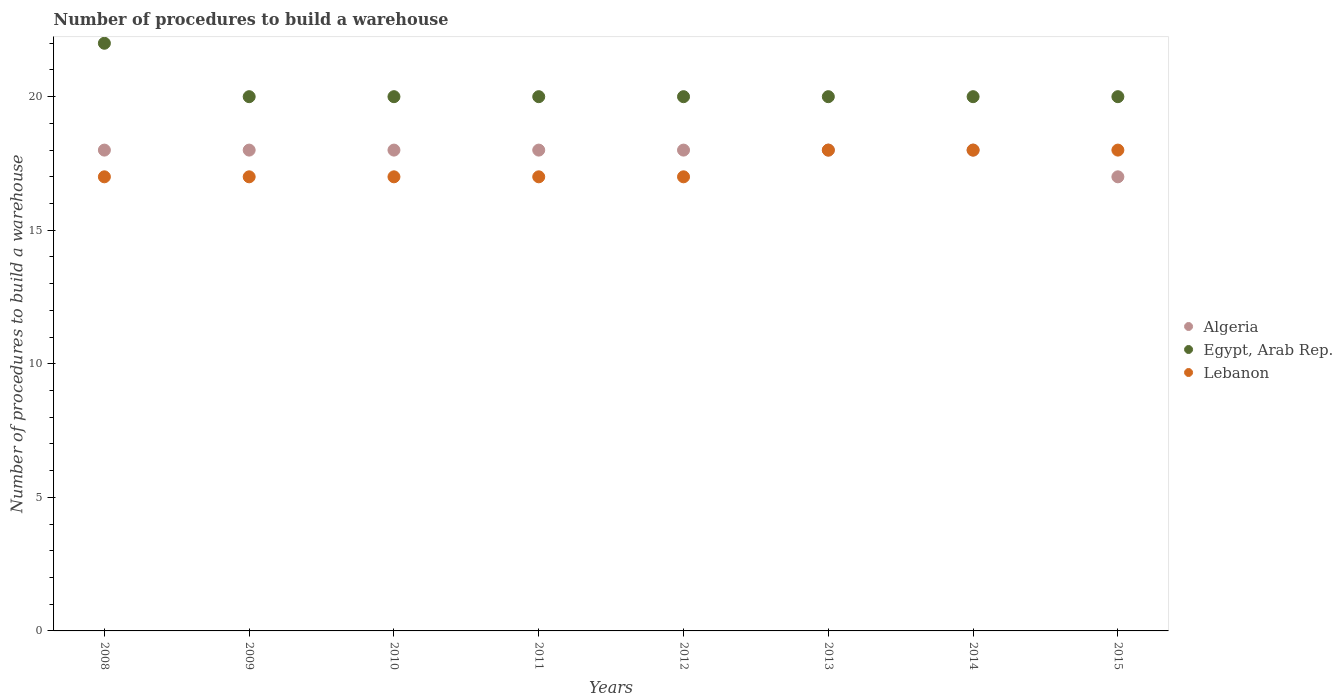What is the number of procedures to build a warehouse in in Lebanon in 2009?
Make the answer very short. 17. Across all years, what is the maximum number of procedures to build a warehouse in in Egypt, Arab Rep.?
Your response must be concise. 22. Across all years, what is the minimum number of procedures to build a warehouse in in Lebanon?
Make the answer very short. 17. In which year was the number of procedures to build a warehouse in in Egypt, Arab Rep. maximum?
Keep it short and to the point. 2008. In which year was the number of procedures to build a warehouse in in Egypt, Arab Rep. minimum?
Give a very brief answer. 2009. What is the total number of procedures to build a warehouse in in Lebanon in the graph?
Give a very brief answer. 139. What is the difference between the number of procedures to build a warehouse in in Algeria in 2008 and that in 2014?
Offer a terse response. 0. What is the difference between the number of procedures to build a warehouse in in Algeria in 2008 and the number of procedures to build a warehouse in in Egypt, Arab Rep. in 2010?
Your answer should be compact. -2. What is the average number of procedures to build a warehouse in in Algeria per year?
Provide a short and direct response. 17.88. In the year 2010, what is the difference between the number of procedures to build a warehouse in in Lebanon and number of procedures to build a warehouse in in Algeria?
Provide a short and direct response. -1. What is the ratio of the number of procedures to build a warehouse in in Algeria in 2008 to that in 2015?
Provide a short and direct response. 1.06. Is the number of procedures to build a warehouse in in Algeria in 2011 less than that in 2012?
Your answer should be compact. No. What is the difference between the highest and the lowest number of procedures to build a warehouse in in Egypt, Arab Rep.?
Provide a short and direct response. 2. Is the sum of the number of procedures to build a warehouse in in Algeria in 2008 and 2011 greater than the maximum number of procedures to build a warehouse in in Lebanon across all years?
Make the answer very short. Yes. Is the number of procedures to build a warehouse in in Egypt, Arab Rep. strictly less than the number of procedures to build a warehouse in in Lebanon over the years?
Offer a very short reply. No. Does the graph contain grids?
Your answer should be very brief. No. Where does the legend appear in the graph?
Offer a very short reply. Center right. How are the legend labels stacked?
Provide a short and direct response. Vertical. What is the title of the graph?
Your response must be concise. Number of procedures to build a warehouse. What is the label or title of the Y-axis?
Keep it short and to the point. Number of procedures to build a warehouse. What is the Number of procedures to build a warehouse of Egypt, Arab Rep. in 2008?
Your answer should be very brief. 22. What is the Number of procedures to build a warehouse in Lebanon in 2008?
Keep it short and to the point. 17. What is the Number of procedures to build a warehouse of Algeria in 2010?
Your answer should be very brief. 18. What is the Number of procedures to build a warehouse of Egypt, Arab Rep. in 2010?
Ensure brevity in your answer.  20. What is the Number of procedures to build a warehouse in Lebanon in 2010?
Provide a succinct answer. 17. What is the Number of procedures to build a warehouse in Algeria in 2012?
Ensure brevity in your answer.  18. What is the Number of procedures to build a warehouse of Egypt, Arab Rep. in 2012?
Your response must be concise. 20. What is the Number of procedures to build a warehouse of Lebanon in 2013?
Make the answer very short. 18. What is the Number of procedures to build a warehouse in Algeria in 2014?
Your response must be concise. 18. What is the Number of procedures to build a warehouse of Lebanon in 2014?
Offer a terse response. 18. What is the Number of procedures to build a warehouse of Lebanon in 2015?
Make the answer very short. 18. Across all years, what is the maximum Number of procedures to build a warehouse of Egypt, Arab Rep.?
Provide a succinct answer. 22. Across all years, what is the minimum Number of procedures to build a warehouse of Algeria?
Offer a terse response. 17. What is the total Number of procedures to build a warehouse of Algeria in the graph?
Your answer should be very brief. 143. What is the total Number of procedures to build a warehouse of Egypt, Arab Rep. in the graph?
Offer a terse response. 162. What is the total Number of procedures to build a warehouse of Lebanon in the graph?
Offer a terse response. 139. What is the difference between the Number of procedures to build a warehouse of Egypt, Arab Rep. in 2008 and that in 2009?
Your response must be concise. 2. What is the difference between the Number of procedures to build a warehouse in Egypt, Arab Rep. in 2008 and that in 2010?
Provide a succinct answer. 2. What is the difference between the Number of procedures to build a warehouse of Algeria in 2008 and that in 2012?
Your answer should be compact. 0. What is the difference between the Number of procedures to build a warehouse in Egypt, Arab Rep. in 2008 and that in 2012?
Give a very brief answer. 2. What is the difference between the Number of procedures to build a warehouse in Lebanon in 2008 and that in 2012?
Offer a very short reply. 0. What is the difference between the Number of procedures to build a warehouse in Egypt, Arab Rep. in 2008 and that in 2013?
Offer a very short reply. 2. What is the difference between the Number of procedures to build a warehouse in Egypt, Arab Rep. in 2008 and that in 2014?
Give a very brief answer. 2. What is the difference between the Number of procedures to build a warehouse in Lebanon in 2008 and that in 2014?
Your answer should be compact. -1. What is the difference between the Number of procedures to build a warehouse of Lebanon in 2008 and that in 2015?
Offer a terse response. -1. What is the difference between the Number of procedures to build a warehouse of Algeria in 2009 and that in 2010?
Provide a succinct answer. 0. What is the difference between the Number of procedures to build a warehouse of Egypt, Arab Rep. in 2009 and that in 2010?
Make the answer very short. 0. What is the difference between the Number of procedures to build a warehouse in Lebanon in 2009 and that in 2010?
Your answer should be very brief. 0. What is the difference between the Number of procedures to build a warehouse in Algeria in 2009 and that in 2011?
Your response must be concise. 0. What is the difference between the Number of procedures to build a warehouse in Egypt, Arab Rep. in 2009 and that in 2011?
Offer a very short reply. 0. What is the difference between the Number of procedures to build a warehouse in Egypt, Arab Rep. in 2009 and that in 2012?
Keep it short and to the point. 0. What is the difference between the Number of procedures to build a warehouse in Lebanon in 2009 and that in 2012?
Give a very brief answer. 0. What is the difference between the Number of procedures to build a warehouse of Egypt, Arab Rep. in 2009 and that in 2013?
Your response must be concise. 0. What is the difference between the Number of procedures to build a warehouse in Lebanon in 2009 and that in 2013?
Ensure brevity in your answer.  -1. What is the difference between the Number of procedures to build a warehouse of Algeria in 2009 and that in 2014?
Provide a succinct answer. 0. What is the difference between the Number of procedures to build a warehouse of Algeria in 2009 and that in 2015?
Your response must be concise. 1. What is the difference between the Number of procedures to build a warehouse in Lebanon in 2009 and that in 2015?
Provide a succinct answer. -1. What is the difference between the Number of procedures to build a warehouse in Egypt, Arab Rep. in 2010 and that in 2012?
Ensure brevity in your answer.  0. What is the difference between the Number of procedures to build a warehouse of Lebanon in 2010 and that in 2012?
Make the answer very short. 0. What is the difference between the Number of procedures to build a warehouse of Algeria in 2010 and that in 2013?
Ensure brevity in your answer.  0. What is the difference between the Number of procedures to build a warehouse of Egypt, Arab Rep. in 2010 and that in 2013?
Provide a succinct answer. 0. What is the difference between the Number of procedures to build a warehouse of Egypt, Arab Rep. in 2010 and that in 2014?
Provide a succinct answer. 0. What is the difference between the Number of procedures to build a warehouse in Algeria in 2011 and that in 2012?
Provide a short and direct response. 0. What is the difference between the Number of procedures to build a warehouse in Egypt, Arab Rep. in 2011 and that in 2012?
Provide a succinct answer. 0. What is the difference between the Number of procedures to build a warehouse in Egypt, Arab Rep. in 2011 and that in 2013?
Offer a terse response. 0. What is the difference between the Number of procedures to build a warehouse in Lebanon in 2011 and that in 2013?
Provide a succinct answer. -1. What is the difference between the Number of procedures to build a warehouse of Algeria in 2011 and that in 2014?
Your response must be concise. 0. What is the difference between the Number of procedures to build a warehouse in Egypt, Arab Rep. in 2011 and that in 2014?
Provide a short and direct response. 0. What is the difference between the Number of procedures to build a warehouse of Lebanon in 2012 and that in 2013?
Your response must be concise. -1. What is the difference between the Number of procedures to build a warehouse of Algeria in 2012 and that in 2014?
Keep it short and to the point. 0. What is the difference between the Number of procedures to build a warehouse in Egypt, Arab Rep. in 2012 and that in 2014?
Provide a short and direct response. 0. What is the difference between the Number of procedures to build a warehouse in Lebanon in 2012 and that in 2014?
Your response must be concise. -1. What is the difference between the Number of procedures to build a warehouse in Algeria in 2012 and that in 2015?
Make the answer very short. 1. What is the difference between the Number of procedures to build a warehouse of Egypt, Arab Rep. in 2012 and that in 2015?
Make the answer very short. 0. What is the difference between the Number of procedures to build a warehouse in Lebanon in 2012 and that in 2015?
Offer a very short reply. -1. What is the difference between the Number of procedures to build a warehouse of Egypt, Arab Rep. in 2013 and that in 2014?
Provide a succinct answer. 0. What is the difference between the Number of procedures to build a warehouse of Lebanon in 2013 and that in 2015?
Provide a succinct answer. 0. What is the difference between the Number of procedures to build a warehouse in Algeria in 2008 and the Number of procedures to build a warehouse in Egypt, Arab Rep. in 2009?
Give a very brief answer. -2. What is the difference between the Number of procedures to build a warehouse in Egypt, Arab Rep. in 2008 and the Number of procedures to build a warehouse in Lebanon in 2010?
Ensure brevity in your answer.  5. What is the difference between the Number of procedures to build a warehouse in Algeria in 2008 and the Number of procedures to build a warehouse in Lebanon in 2011?
Offer a terse response. 1. What is the difference between the Number of procedures to build a warehouse of Egypt, Arab Rep. in 2008 and the Number of procedures to build a warehouse of Lebanon in 2011?
Make the answer very short. 5. What is the difference between the Number of procedures to build a warehouse of Algeria in 2008 and the Number of procedures to build a warehouse of Egypt, Arab Rep. in 2012?
Your answer should be very brief. -2. What is the difference between the Number of procedures to build a warehouse in Algeria in 2008 and the Number of procedures to build a warehouse in Lebanon in 2012?
Provide a succinct answer. 1. What is the difference between the Number of procedures to build a warehouse in Egypt, Arab Rep. in 2008 and the Number of procedures to build a warehouse in Lebanon in 2014?
Keep it short and to the point. 4. What is the difference between the Number of procedures to build a warehouse in Algeria in 2008 and the Number of procedures to build a warehouse in Egypt, Arab Rep. in 2015?
Your answer should be compact. -2. What is the difference between the Number of procedures to build a warehouse of Algeria in 2009 and the Number of procedures to build a warehouse of Egypt, Arab Rep. in 2010?
Offer a terse response. -2. What is the difference between the Number of procedures to build a warehouse in Algeria in 2009 and the Number of procedures to build a warehouse in Lebanon in 2010?
Ensure brevity in your answer.  1. What is the difference between the Number of procedures to build a warehouse of Algeria in 2009 and the Number of procedures to build a warehouse of Egypt, Arab Rep. in 2011?
Give a very brief answer. -2. What is the difference between the Number of procedures to build a warehouse of Algeria in 2009 and the Number of procedures to build a warehouse of Egypt, Arab Rep. in 2012?
Ensure brevity in your answer.  -2. What is the difference between the Number of procedures to build a warehouse in Egypt, Arab Rep. in 2009 and the Number of procedures to build a warehouse in Lebanon in 2012?
Give a very brief answer. 3. What is the difference between the Number of procedures to build a warehouse in Algeria in 2009 and the Number of procedures to build a warehouse in Egypt, Arab Rep. in 2013?
Make the answer very short. -2. What is the difference between the Number of procedures to build a warehouse in Egypt, Arab Rep. in 2009 and the Number of procedures to build a warehouse in Lebanon in 2013?
Your answer should be compact. 2. What is the difference between the Number of procedures to build a warehouse of Algeria in 2009 and the Number of procedures to build a warehouse of Lebanon in 2014?
Keep it short and to the point. 0. What is the difference between the Number of procedures to build a warehouse in Egypt, Arab Rep. in 2009 and the Number of procedures to build a warehouse in Lebanon in 2014?
Give a very brief answer. 2. What is the difference between the Number of procedures to build a warehouse of Egypt, Arab Rep. in 2009 and the Number of procedures to build a warehouse of Lebanon in 2015?
Your answer should be compact. 2. What is the difference between the Number of procedures to build a warehouse of Algeria in 2010 and the Number of procedures to build a warehouse of Lebanon in 2012?
Your response must be concise. 1. What is the difference between the Number of procedures to build a warehouse in Egypt, Arab Rep. in 2010 and the Number of procedures to build a warehouse in Lebanon in 2012?
Keep it short and to the point. 3. What is the difference between the Number of procedures to build a warehouse in Algeria in 2010 and the Number of procedures to build a warehouse in Lebanon in 2014?
Your response must be concise. 0. What is the difference between the Number of procedures to build a warehouse in Algeria in 2010 and the Number of procedures to build a warehouse in Lebanon in 2015?
Give a very brief answer. 0. What is the difference between the Number of procedures to build a warehouse of Egypt, Arab Rep. in 2010 and the Number of procedures to build a warehouse of Lebanon in 2015?
Give a very brief answer. 2. What is the difference between the Number of procedures to build a warehouse of Egypt, Arab Rep. in 2011 and the Number of procedures to build a warehouse of Lebanon in 2012?
Make the answer very short. 3. What is the difference between the Number of procedures to build a warehouse of Algeria in 2011 and the Number of procedures to build a warehouse of Egypt, Arab Rep. in 2014?
Give a very brief answer. -2. What is the difference between the Number of procedures to build a warehouse of Egypt, Arab Rep. in 2011 and the Number of procedures to build a warehouse of Lebanon in 2014?
Ensure brevity in your answer.  2. What is the difference between the Number of procedures to build a warehouse of Algeria in 2011 and the Number of procedures to build a warehouse of Egypt, Arab Rep. in 2015?
Ensure brevity in your answer.  -2. What is the difference between the Number of procedures to build a warehouse of Algeria in 2012 and the Number of procedures to build a warehouse of Egypt, Arab Rep. in 2013?
Ensure brevity in your answer.  -2. What is the difference between the Number of procedures to build a warehouse in Algeria in 2012 and the Number of procedures to build a warehouse in Lebanon in 2013?
Offer a very short reply. 0. What is the difference between the Number of procedures to build a warehouse in Egypt, Arab Rep. in 2012 and the Number of procedures to build a warehouse in Lebanon in 2013?
Your answer should be very brief. 2. What is the difference between the Number of procedures to build a warehouse in Algeria in 2012 and the Number of procedures to build a warehouse in Lebanon in 2014?
Give a very brief answer. 0. What is the difference between the Number of procedures to build a warehouse of Algeria in 2012 and the Number of procedures to build a warehouse of Egypt, Arab Rep. in 2015?
Your answer should be compact. -2. What is the difference between the Number of procedures to build a warehouse of Algeria in 2012 and the Number of procedures to build a warehouse of Lebanon in 2015?
Make the answer very short. 0. What is the difference between the Number of procedures to build a warehouse in Egypt, Arab Rep. in 2012 and the Number of procedures to build a warehouse in Lebanon in 2015?
Offer a very short reply. 2. What is the difference between the Number of procedures to build a warehouse of Algeria in 2013 and the Number of procedures to build a warehouse of Egypt, Arab Rep. in 2014?
Your answer should be very brief. -2. What is the difference between the Number of procedures to build a warehouse in Algeria in 2013 and the Number of procedures to build a warehouse in Lebanon in 2015?
Keep it short and to the point. 0. What is the difference between the Number of procedures to build a warehouse of Egypt, Arab Rep. in 2014 and the Number of procedures to build a warehouse of Lebanon in 2015?
Provide a succinct answer. 2. What is the average Number of procedures to build a warehouse of Algeria per year?
Keep it short and to the point. 17.88. What is the average Number of procedures to build a warehouse in Egypt, Arab Rep. per year?
Your answer should be compact. 20.25. What is the average Number of procedures to build a warehouse of Lebanon per year?
Make the answer very short. 17.38. In the year 2009, what is the difference between the Number of procedures to build a warehouse in Algeria and Number of procedures to build a warehouse in Lebanon?
Your answer should be compact. 1. In the year 2011, what is the difference between the Number of procedures to build a warehouse in Algeria and Number of procedures to build a warehouse in Egypt, Arab Rep.?
Your answer should be very brief. -2. In the year 2011, what is the difference between the Number of procedures to build a warehouse of Algeria and Number of procedures to build a warehouse of Lebanon?
Keep it short and to the point. 1. In the year 2012, what is the difference between the Number of procedures to build a warehouse in Algeria and Number of procedures to build a warehouse in Egypt, Arab Rep.?
Give a very brief answer. -2. In the year 2013, what is the difference between the Number of procedures to build a warehouse in Algeria and Number of procedures to build a warehouse in Lebanon?
Your response must be concise. 0. In the year 2014, what is the difference between the Number of procedures to build a warehouse in Algeria and Number of procedures to build a warehouse in Egypt, Arab Rep.?
Offer a terse response. -2. In the year 2014, what is the difference between the Number of procedures to build a warehouse in Egypt, Arab Rep. and Number of procedures to build a warehouse in Lebanon?
Ensure brevity in your answer.  2. In the year 2015, what is the difference between the Number of procedures to build a warehouse in Algeria and Number of procedures to build a warehouse in Egypt, Arab Rep.?
Make the answer very short. -3. In the year 2015, what is the difference between the Number of procedures to build a warehouse of Egypt, Arab Rep. and Number of procedures to build a warehouse of Lebanon?
Your answer should be compact. 2. What is the ratio of the Number of procedures to build a warehouse in Algeria in 2008 to that in 2009?
Ensure brevity in your answer.  1. What is the ratio of the Number of procedures to build a warehouse in Lebanon in 2008 to that in 2009?
Your answer should be compact. 1. What is the ratio of the Number of procedures to build a warehouse in Lebanon in 2008 to that in 2010?
Provide a succinct answer. 1. What is the ratio of the Number of procedures to build a warehouse of Egypt, Arab Rep. in 2008 to that in 2011?
Give a very brief answer. 1.1. What is the ratio of the Number of procedures to build a warehouse in Lebanon in 2008 to that in 2012?
Keep it short and to the point. 1. What is the ratio of the Number of procedures to build a warehouse in Algeria in 2008 to that in 2013?
Offer a terse response. 1. What is the ratio of the Number of procedures to build a warehouse of Lebanon in 2008 to that in 2013?
Provide a short and direct response. 0.94. What is the ratio of the Number of procedures to build a warehouse in Lebanon in 2008 to that in 2014?
Provide a short and direct response. 0.94. What is the ratio of the Number of procedures to build a warehouse in Algeria in 2008 to that in 2015?
Give a very brief answer. 1.06. What is the ratio of the Number of procedures to build a warehouse in Egypt, Arab Rep. in 2008 to that in 2015?
Your answer should be very brief. 1.1. What is the ratio of the Number of procedures to build a warehouse of Algeria in 2009 to that in 2011?
Ensure brevity in your answer.  1. What is the ratio of the Number of procedures to build a warehouse of Lebanon in 2009 to that in 2011?
Ensure brevity in your answer.  1. What is the ratio of the Number of procedures to build a warehouse of Algeria in 2009 to that in 2012?
Keep it short and to the point. 1. What is the ratio of the Number of procedures to build a warehouse in Egypt, Arab Rep. in 2009 to that in 2012?
Your response must be concise. 1. What is the ratio of the Number of procedures to build a warehouse of Lebanon in 2009 to that in 2012?
Give a very brief answer. 1. What is the ratio of the Number of procedures to build a warehouse in Algeria in 2009 to that in 2013?
Give a very brief answer. 1. What is the ratio of the Number of procedures to build a warehouse of Egypt, Arab Rep. in 2009 to that in 2013?
Provide a short and direct response. 1. What is the ratio of the Number of procedures to build a warehouse of Egypt, Arab Rep. in 2009 to that in 2014?
Keep it short and to the point. 1. What is the ratio of the Number of procedures to build a warehouse in Algeria in 2009 to that in 2015?
Make the answer very short. 1.06. What is the ratio of the Number of procedures to build a warehouse in Algeria in 2010 to that in 2011?
Provide a short and direct response. 1. What is the ratio of the Number of procedures to build a warehouse of Lebanon in 2010 to that in 2011?
Your answer should be compact. 1. What is the ratio of the Number of procedures to build a warehouse of Lebanon in 2010 to that in 2012?
Your answer should be compact. 1. What is the ratio of the Number of procedures to build a warehouse of Egypt, Arab Rep. in 2010 to that in 2013?
Offer a terse response. 1. What is the ratio of the Number of procedures to build a warehouse of Lebanon in 2010 to that in 2013?
Your answer should be compact. 0.94. What is the ratio of the Number of procedures to build a warehouse of Algeria in 2010 to that in 2014?
Provide a succinct answer. 1. What is the ratio of the Number of procedures to build a warehouse in Egypt, Arab Rep. in 2010 to that in 2014?
Provide a succinct answer. 1. What is the ratio of the Number of procedures to build a warehouse in Lebanon in 2010 to that in 2014?
Offer a terse response. 0.94. What is the ratio of the Number of procedures to build a warehouse in Algeria in 2010 to that in 2015?
Give a very brief answer. 1.06. What is the ratio of the Number of procedures to build a warehouse of Egypt, Arab Rep. in 2010 to that in 2015?
Your answer should be very brief. 1. What is the ratio of the Number of procedures to build a warehouse of Algeria in 2011 to that in 2012?
Make the answer very short. 1. What is the ratio of the Number of procedures to build a warehouse in Egypt, Arab Rep. in 2011 to that in 2012?
Your answer should be compact. 1. What is the ratio of the Number of procedures to build a warehouse of Egypt, Arab Rep. in 2011 to that in 2013?
Give a very brief answer. 1. What is the ratio of the Number of procedures to build a warehouse of Lebanon in 2011 to that in 2013?
Keep it short and to the point. 0.94. What is the ratio of the Number of procedures to build a warehouse of Algeria in 2011 to that in 2014?
Ensure brevity in your answer.  1. What is the ratio of the Number of procedures to build a warehouse in Lebanon in 2011 to that in 2014?
Offer a terse response. 0.94. What is the ratio of the Number of procedures to build a warehouse of Algeria in 2011 to that in 2015?
Make the answer very short. 1.06. What is the ratio of the Number of procedures to build a warehouse of Egypt, Arab Rep. in 2011 to that in 2015?
Offer a terse response. 1. What is the ratio of the Number of procedures to build a warehouse in Egypt, Arab Rep. in 2012 to that in 2013?
Make the answer very short. 1. What is the ratio of the Number of procedures to build a warehouse of Lebanon in 2012 to that in 2013?
Your response must be concise. 0.94. What is the ratio of the Number of procedures to build a warehouse of Algeria in 2012 to that in 2014?
Offer a very short reply. 1. What is the ratio of the Number of procedures to build a warehouse of Egypt, Arab Rep. in 2012 to that in 2014?
Your answer should be very brief. 1. What is the ratio of the Number of procedures to build a warehouse in Algeria in 2012 to that in 2015?
Provide a short and direct response. 1.06. What is the ratio of the Number of procedures to build a warehouse in Egypt, Arab Rep. in 2012 to that in 2015?
Give a very brief answer. 1. What is the ratio of the Number of procedures to build a warehouse of Lebanon in 2012 to that in 2015?
Your answer should be compact. 0.94. What is the ratio of the Number of procedures to build a warehouse in Algeria in 2013 to that in 2014?
Provide a succinct answer. 1. What is the ratio of the Number of procedures to build a warehouse in Algeria in 2013 to that in 2015?
Make the answer very short. 1.06. What is the ratio of the Number of procedures to build a warehouse in Algeria in 2014 to that in 2015?
Provide a short and direct response. 1.06. What is the ratio of the Number of procedures to build a warehouse of Lebanon in 2014 to that in 2015?
Ensure brevity in your answer.  1. What is the difference between the highest and the second highest Number of procedures to build a warehouse in Lebanon?
Offer a very short reply. 0. 